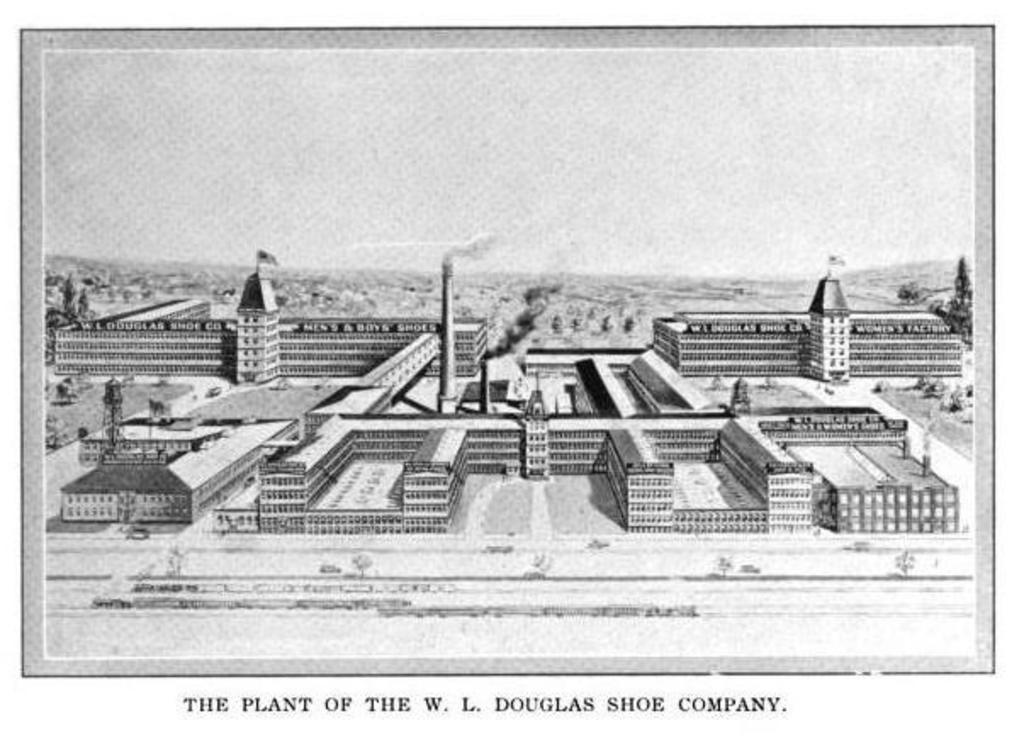What type of structures can be seen in the image? There are buildings in the image. What part of the natural environment is visible in the image? The sky is visible in the image. Is there any text present in the image? Yes, there is text written on the image. What is the color scheme of the image? The image is in black and white. What type of desk is visible in the image? There is no desk present in the image. How does the spy use the fold in the image? There is no spy or fold present in the image. 